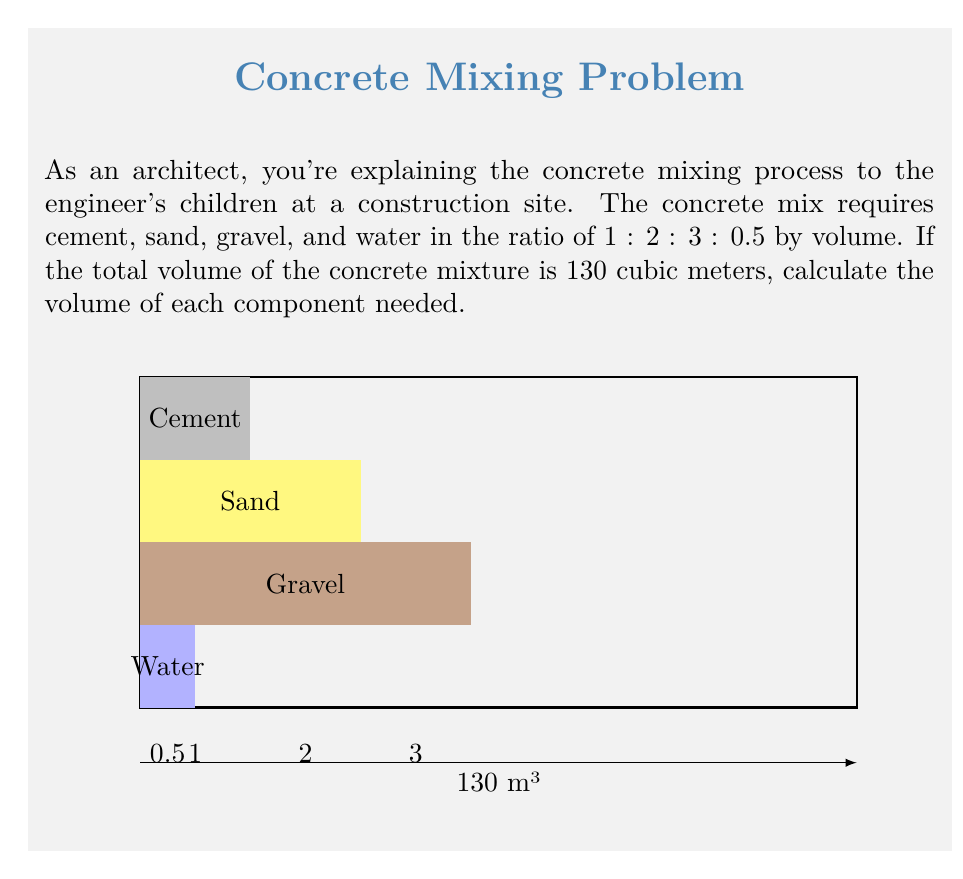Provide a solution to this math problem. Let's solve this step-by-step:

1) First, let's identify the ratio of components:
   Cement : Sand : Gravel : Water
   1 : 2 : 3 : 0.5

2) To find the total parts, we sum up all ratios:
   $1 + 2 + 3 + 0.5 = 6.5$ parts

3) Now, we can calculate the volume of one part:
   $\text{Volume of one part} = \frac{\text{Total volume}}{\text{Total parts}} = \frac{130 \text{ m}^3}{6.5} = 20 \text{ m}^3$

4) Using this, we can calculate the volume of each component:

   Cement: $1 \times 20 \text{ m}^3 = 20 \text{ m}^3$
   Sand: $2 \times 20 \text{ m}^3 = 40 \text{ m}^3$
   Gravel: $3 \times 20 \text{ m}^3 = 60 \text{ m}^3$
   Water: $0.5 \times 20 \text{ m}^3 = 10 \text{ m}^3$

5) Let's verify: $20 + 40 + 60 + 10 = 130 \text{ m}^3$, which matches our total volume.
Answer: Cement: 20 m³, Sand: 40 m³, Gravel: 60 m³, Water: 10 m³ 